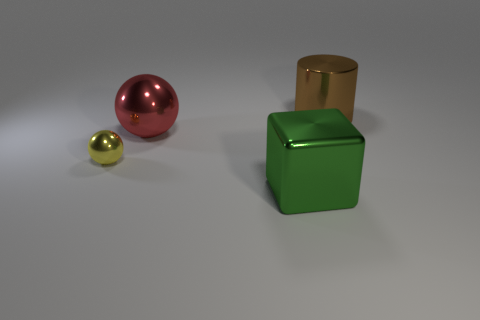What is the shape of the brown metallic thing?
Ensure brevity in your answer.  Cylinder. Is the size of the green shiny thing the same as the yellow metal object?
Offer a terse response. No. The big thing in front of the large red shiny object has what shape?
Give a very brief answer. Cube. What color is the large sphere behind the thing in front of the small metal ball?
Provide a succinct answer. Red. There is a shiny object to the right of the big green cube; is its shape the same as the tiny yellow shiny object behind the large block?
Give a very brief answer. No. What shape is the green object that is the same size as the red thing?
Your answer should be very brief. Cube. What is the color of the big cube that is the same material as the cylinder?
Provide a succinct answer. Green. There is a yellow object; is it the same shape as the brown metal thing behind the small yellow sphere?
Offer a very short reply. No. What is the material of the red ball that is the same size as the green metal object?
Ensure brevity in your answer.  Metal. Is there a rubber thing that has the same color as the block?
Provide a succinct answer. No. 